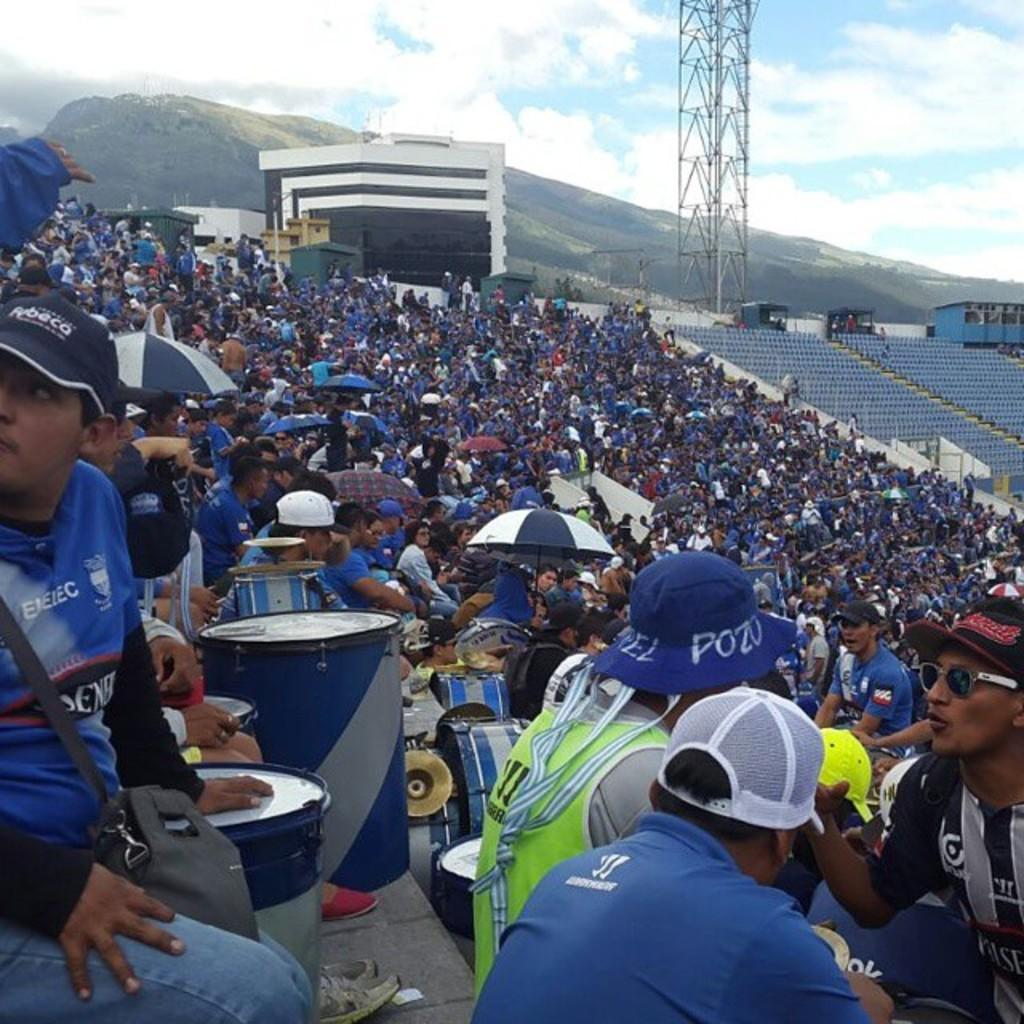What is the primary subject of the image? There are people in the image, likely representing an audience. What can be seen in the background of the image? There is a tower and a mountain in the background of the image. How many wings does the rat have in the image? There is no rat present in the image, so it is not possible to determine the number of wings it might have. 